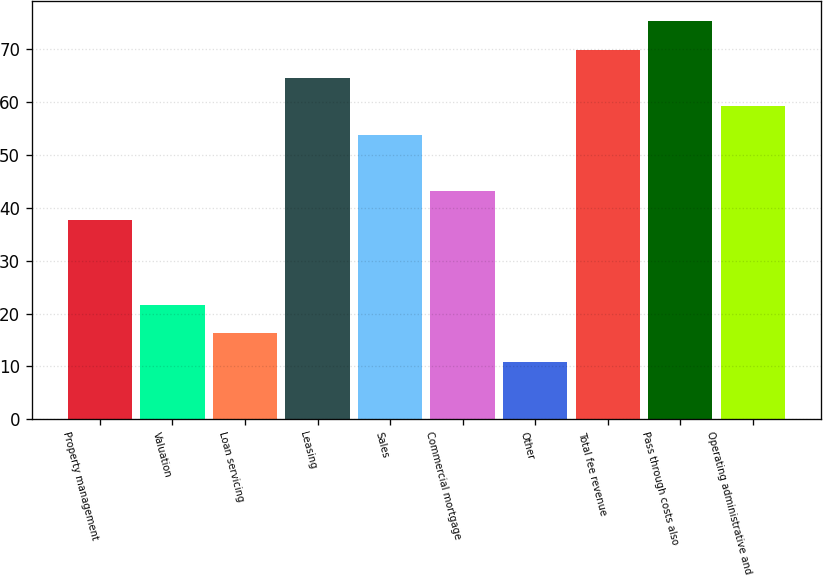<chart> <loc_0><loc_0><loc_500><loc_500><bar_chart><fcel>Property management<fcel>Valuation<fcel>Loan servicing<fcel>Leasing<fcel>Sales<fcel>Commercial mortgage<fcel>Other<fcel>Total fee revenue<fcel>Pass through costs also<fcel>Operating administrative and<nl><fcel>37.76<fcel>21.65<fcel>16.28<fcel>64.61<fcel>53.87<fcel>43.13<fcel>10.91<fcel>69.98<fcel>75.35<fcel>59.24<nl></chart> 